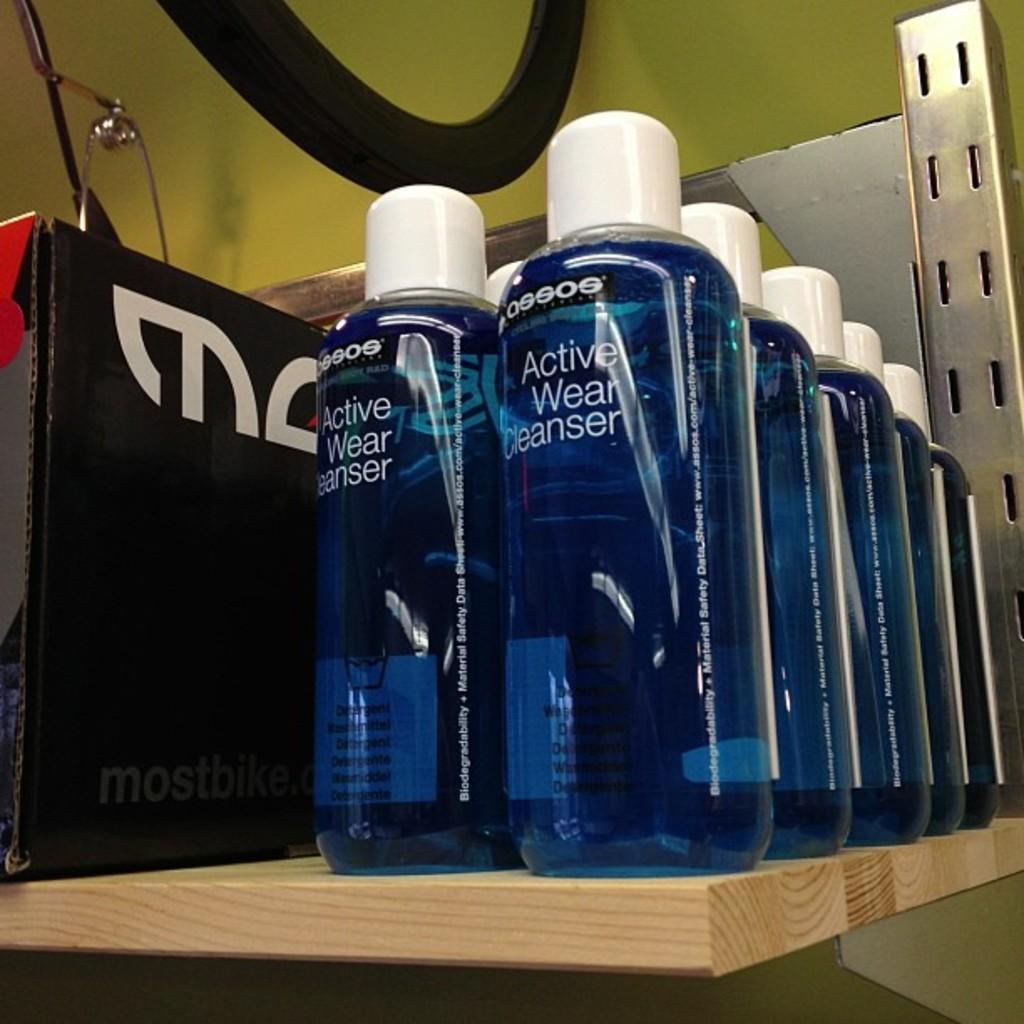<image>
Describe the image concisely. A row of bottles with blue liquid in them labeled Active Wear Cleanser. 